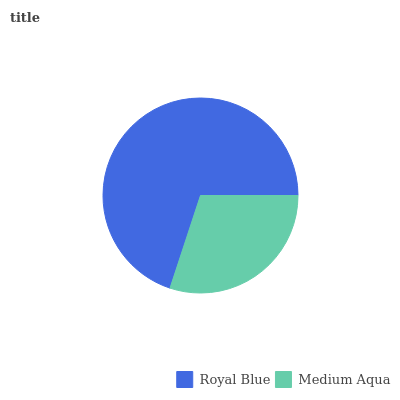Is Medium Aqua the minimum?
Answer yes or no. Yes. Is Royal Blue the maximum?
Answer yes or no. Yes. Is Medium Aqua the maximum?
Answer yes or no. No. Is Royal Blue greater than Medium Aqua?
Answer yes or no. Yes. Is Medium Aqua less than Royal Blue?
Answer yes or no. Yes. Is Medium Aqua greater than Royal Blue?
Answer yes or no. No. Is Royal Blue less than Medium Aqua?
Answer yes or no. No. Is Royal Blue the high median?
Answer yes or no. Yes. Is Medium Aqua the low median?
Answer yes or no. Yes. Is Medium Aqua the high median?
Answer yes or no. No. Is Royal Blue the low median?
Answer yes or no. No. 